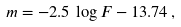<formula> <loc_0><loc_0><loc_500><loc_500>m = - 2 . 5 \, \log F - 1 3 . 7 4 \, ,</formula> 